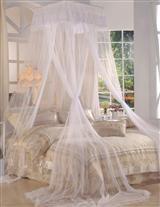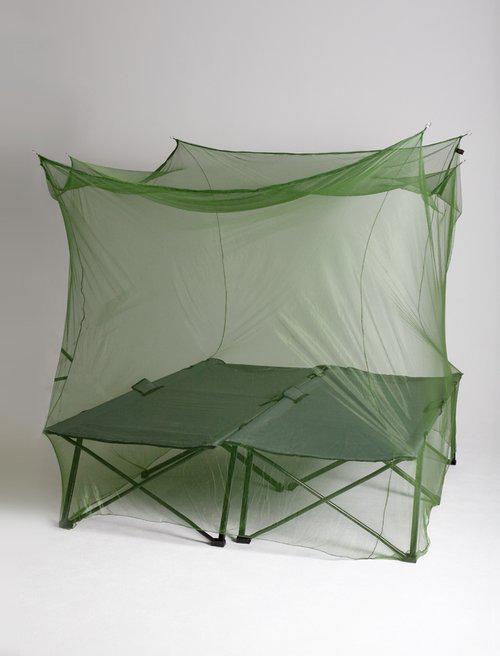The first image is the image on the left, the second image is the image on the right. Evaluate the accuracy of this statement regarding the images: "Green netting hangs over two cots in one of the images.". Is it true? Answer yes or no. Yes. The first image is the image on the left, the second image is the image on the right. For the images shown, is this caption "There are two canopies and at least one is green a square." true? Answer yes or no. Yes. 